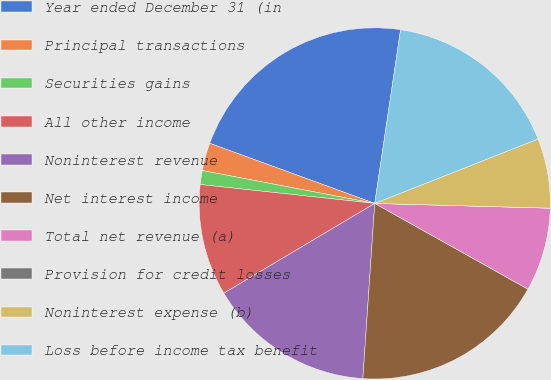<chart> <loc_0><loc_0><loc_500><loc_500><pie_chart><fcel>Year ended December 31 (in<fcel>Principal transactions<fcel>Securities gains<fcel>All other income<fcel>Noninterest revenue<fcel>Net interest income<fcel>Total net revenue (a)<fcel>Provision for credit losses<fcel>Noninterest expense (b)<fcel>Loss before income tax benefit<nl><fcel>21.79%<fcel>2.56%<fcel>1.28%<fcel>10.26%<fcel>15.38%<fcel>17.95%<fcel>7.69%<fcel>0.0%<fcel>6.41%<fcel>16.67%<nl></chart> 